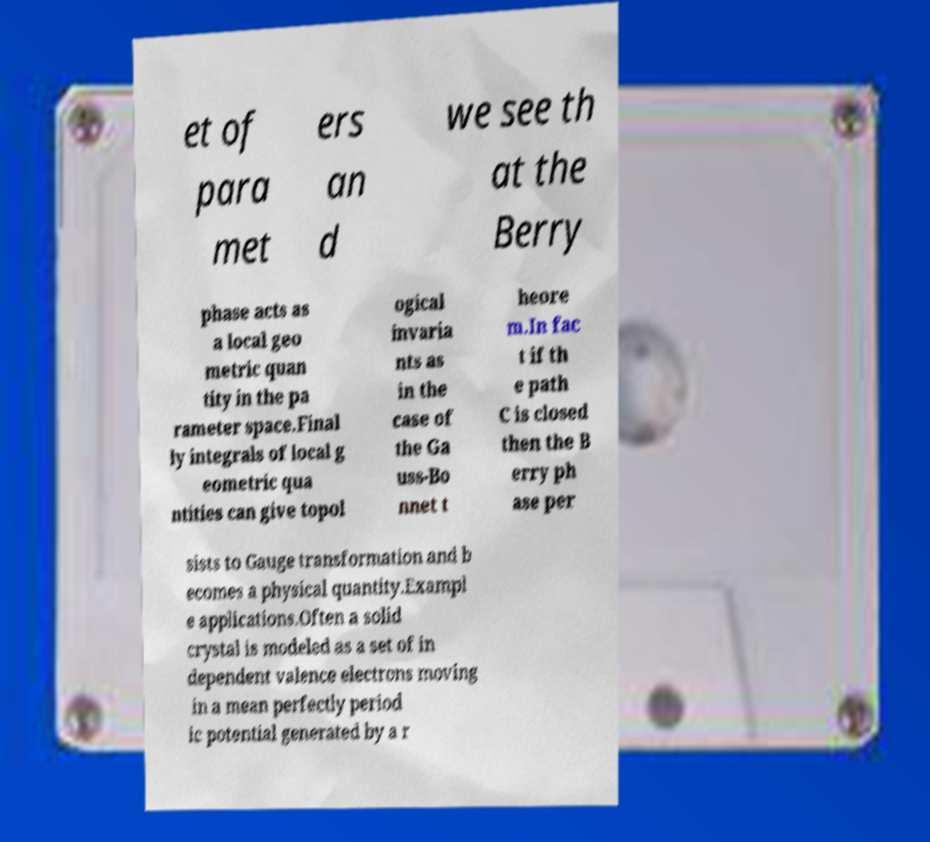Please read and relay the text visible in this image. What does it say? et of para met ers an d we see th at the Berry phase acts as a local geo metric quan tity in the pa rameter space.Final ly integrals of local g eometric qua ntities can give topol ogical invaria nts as in the case of the Ga uss-Bo nnet t heore m.In fac t if th e path C is closed then the B erry ph ase per sists to Gauge transformation and b ecomes a physical quantity.Exampl e applications.Often a solid crystal is modeled as a set of in dependent valence electrons moving in a mean perfectly period ic potential generated by a r 